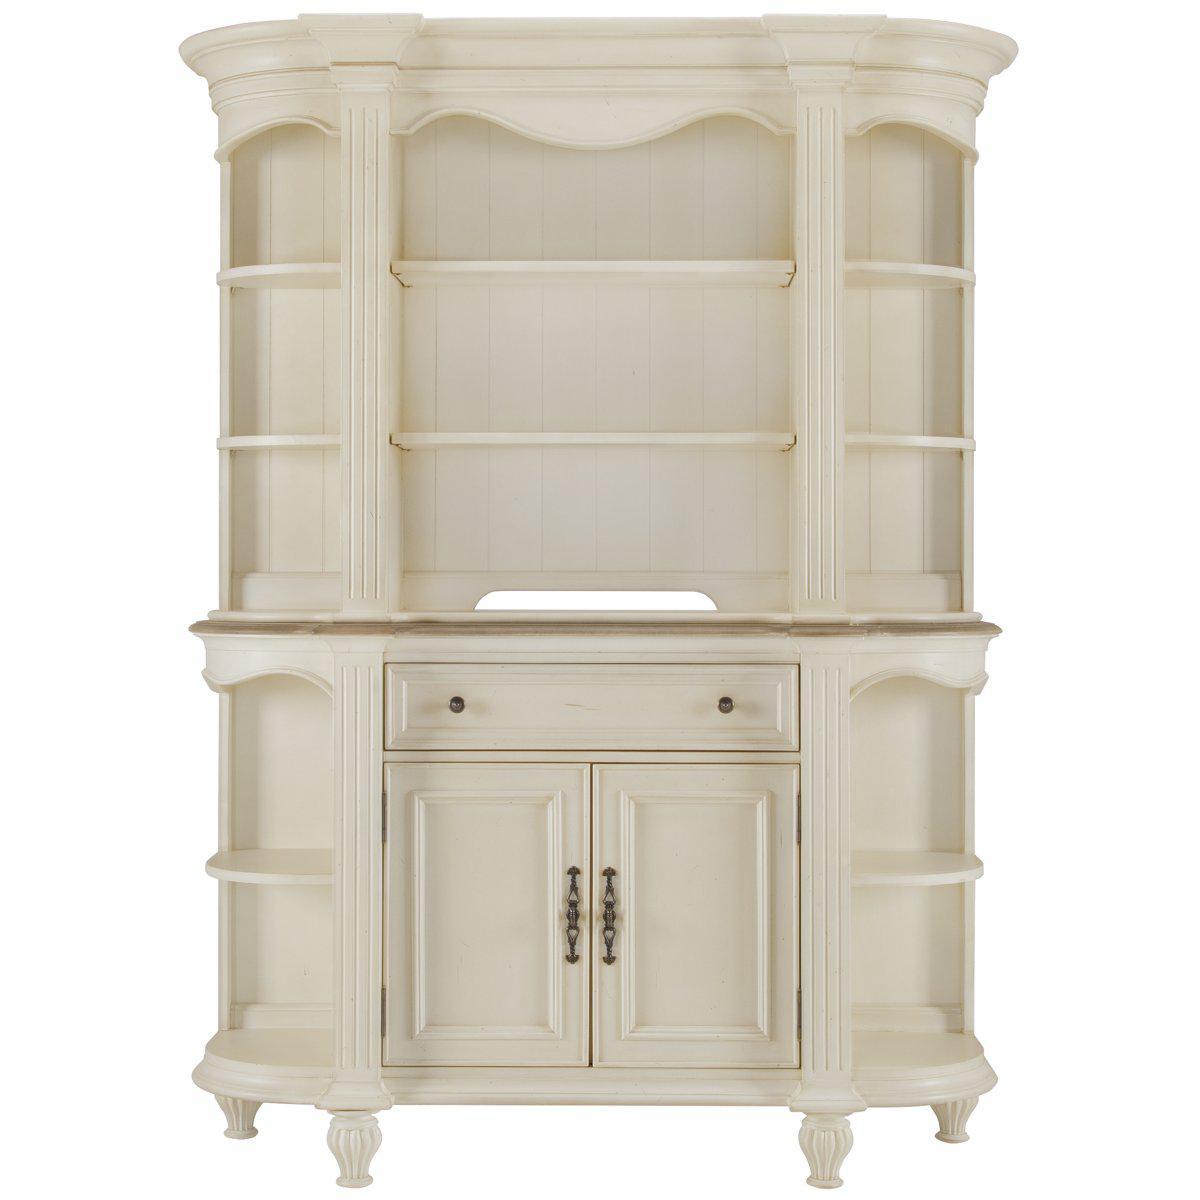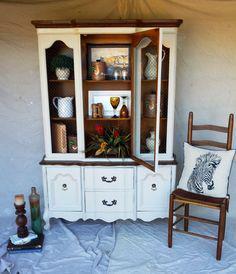The first image is the image on the left, the second image is the image on the right. Evaluate the accuracy of this statement regarding the images: "There are objects in the white cabinet in the image on the left.". Is it true? Answer yes or no. No. The first image is the image on the left, the second image is the image on the right. Analyze the images presented: Is the assertion "The right image contains a chair." valid? Answer yes or no. Yes. 